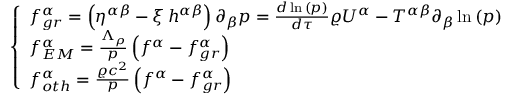<formula> <loc_0><loc_0><loc_500><loc_500>\left \{ \begin{array} { l l } { f _ { g r } ^ { \alpha } = \left ( \eta ^ { \alpha \beta } - \xi \, h ^ { \alpha \beta } \right ) \partial _ { \beta } p = \frac { d { \, \ln { ( p ) } } } { d \tau } \varrho U ^ { \alpha } - T ^ { \alpha \beta } \partial _ { \beta } \ln { ( p ) } } \\ { f _ { E M } ^ { \alpha } = \frac { \Lambda _ { \rho } } { p } \left ( f ^ { \alpha } - f _ { g r } ^ { \alpha } \right ) } \\ { f _ { o t h } ^ { \alpha } = \frac { \varrho c ^ { 2 } } { p } \left ( f ^ { \alpha } - f _ { g r } ^ { \alpha } \right ) } \end{array}</formula> 